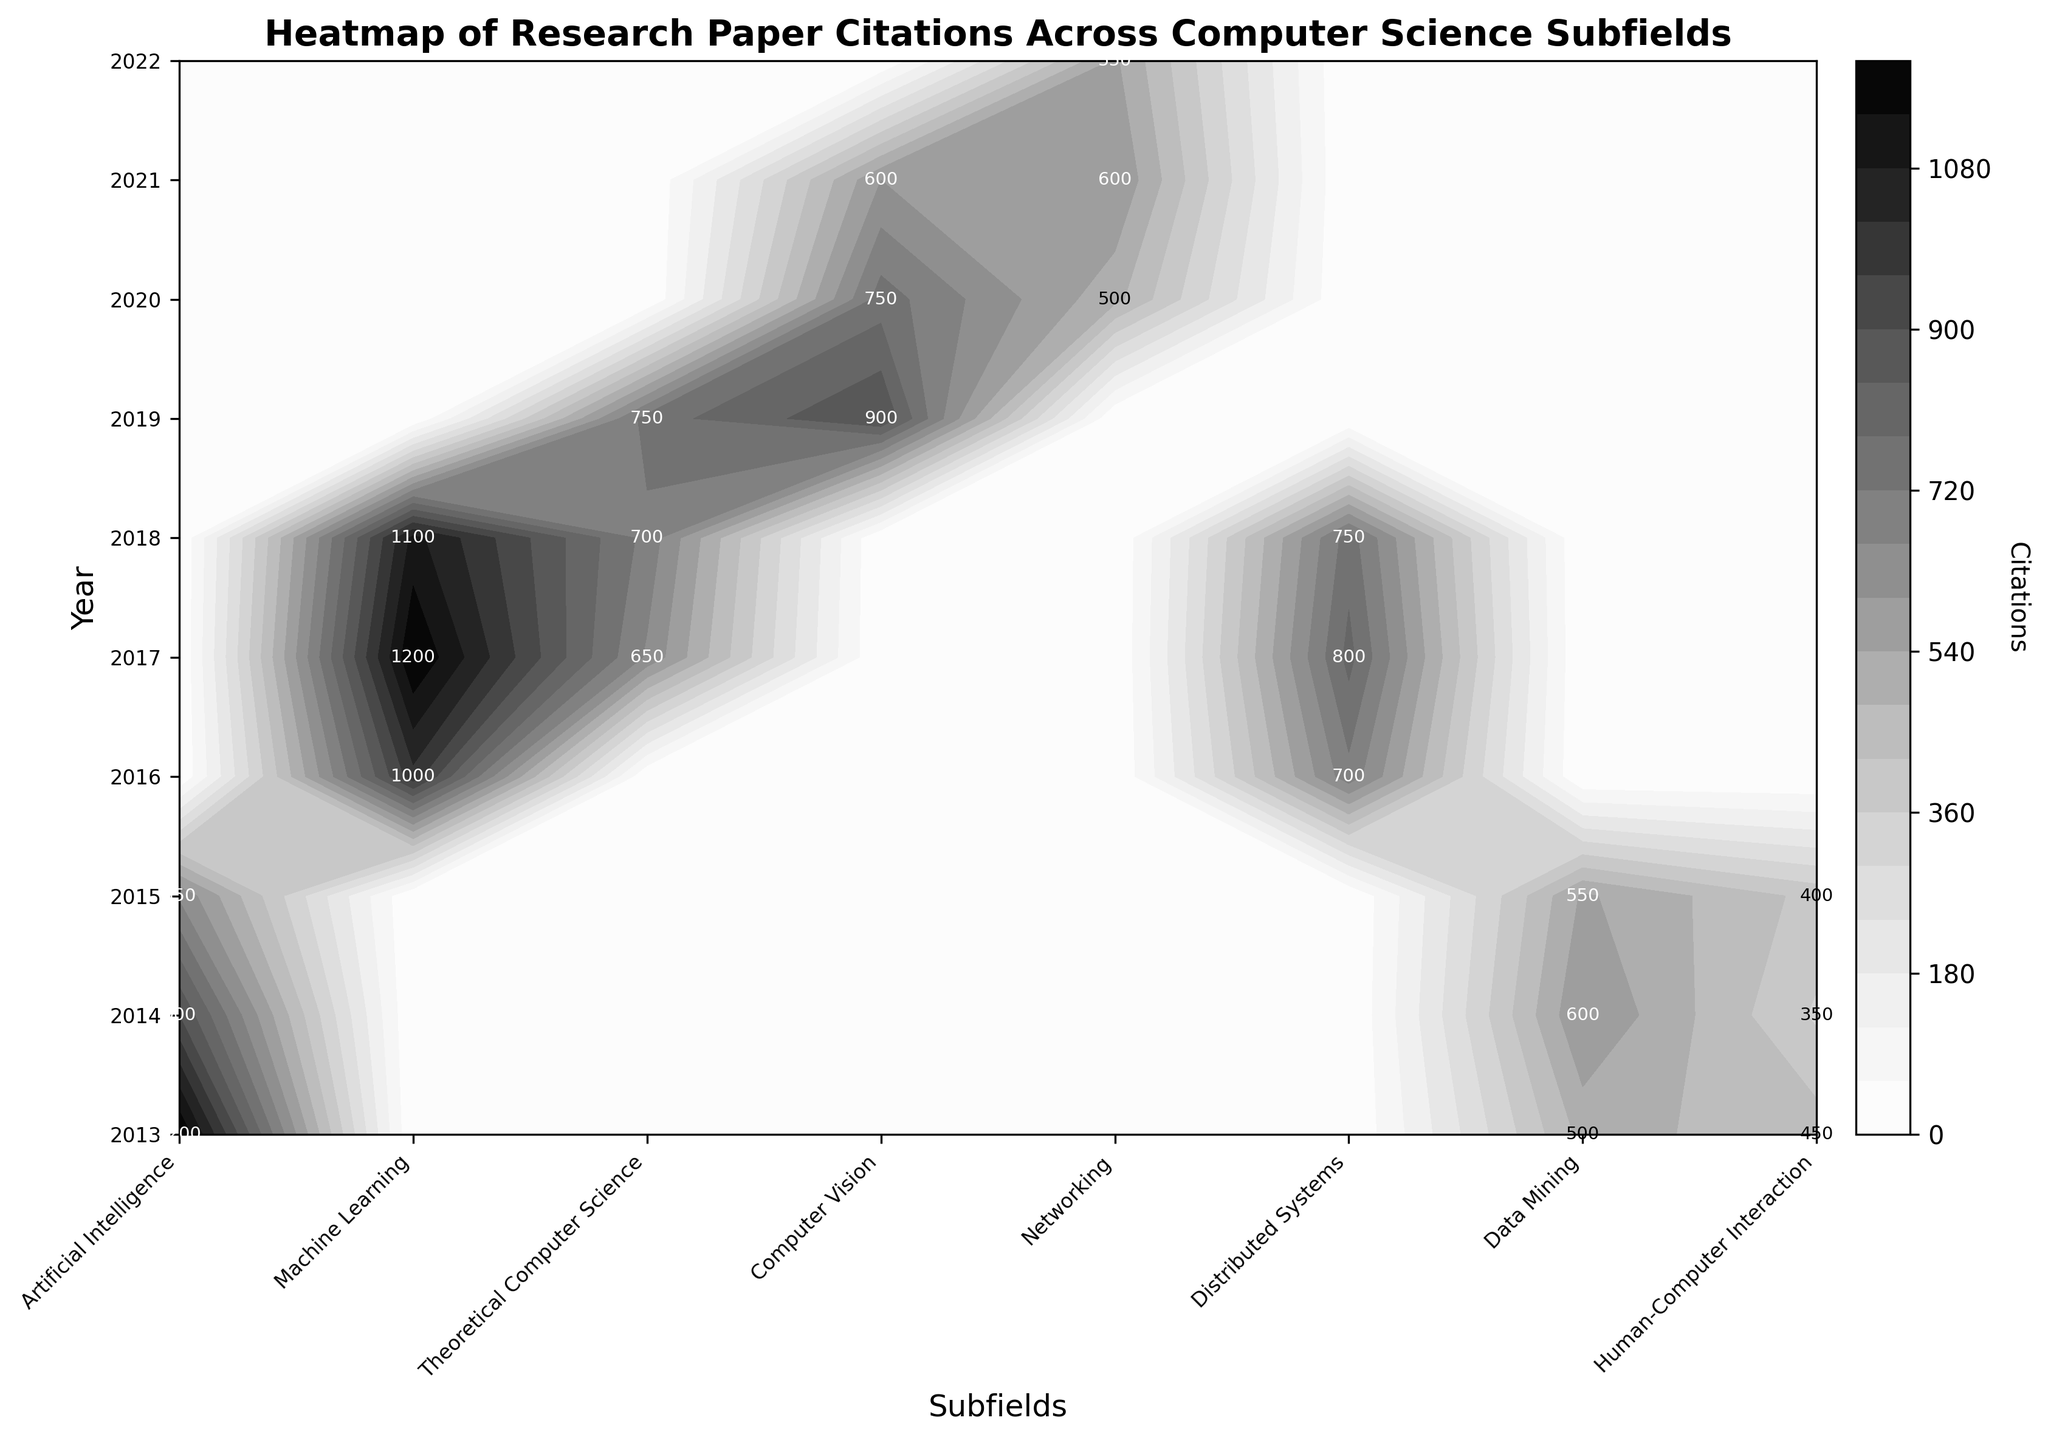What's the title of the figure? The title is typically positioned at the top of the plot. Here, it is clearly written at the top of the figure.
Answer: Heatmap of Research Paper Citations Across Computer Science Subfields What is the highest number of citations for Computer Vision papers? Look for the section labeled 'Computer Vision' and identify the highest number shown within that section.
Answer: 1200 In which year did 'Human-Computer Interaction' have the most citations? Check the annotations within the 'Human-Computer Interaction' column for the highest number and note its corresponding year.
Answer: 2021 Which subfield had the highest number of citations in 2014? Look along the row corresponding to the year 2014 and identify the highest citation count among all subfields.
Answer: Artificial Intelligence How many subfields had citations over 1000? Count the subfields where there are any contour labels indicating citations over 1000.
Answer: 2 Which subfield showed the largest increase in citations from 2015 to 2016? Compare the citation numbers for 2015 and 2016 for each subfield and find the one with the greatest increase.
Answer: Computer Vision Which subfield had the most consistent citation counts across all years? Examine all subfields to see which one shows the least variability in citation counts from year to year.
Answer: Theoretical Computer Science From 2017 to 2018, did 'Machine Learning' citations increase or decrease? Compare the citation numbers for 'Machine Learning' in 2017 with those in 2018.
Answer: Decrease What is the total citation count for 'Distributed Systems' across all years? Add the citation counts for 'Distributed Systems' from each year they are listed.
Answer: 2250 Between 'Networking' and 'Data Mining', which had a higher cumulative citation count from 2013 to 2021? Sum the citations for 'Networking' and 'Data Mining' over the stated years and compare the two totals.
Answer: Data Mining 